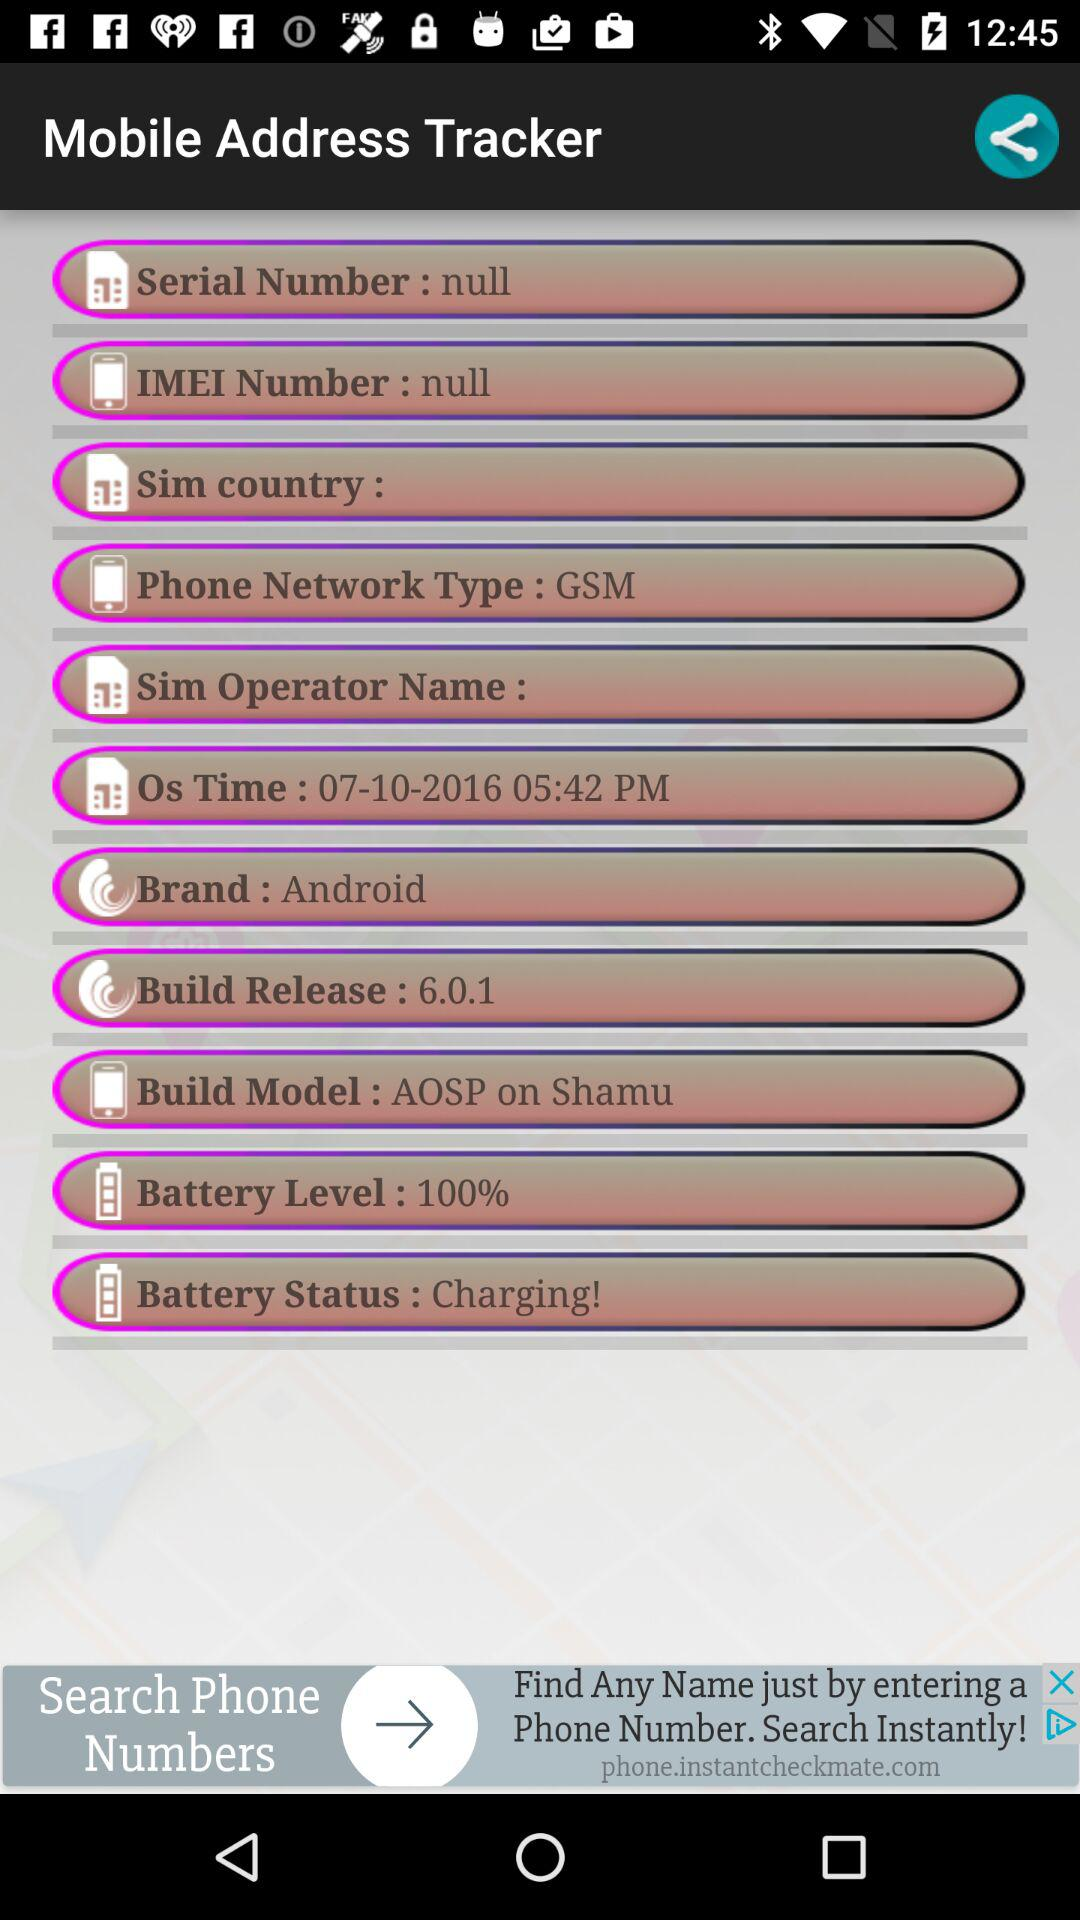What is the "Battery Status"? The "Battery Status" is "Charging!". 